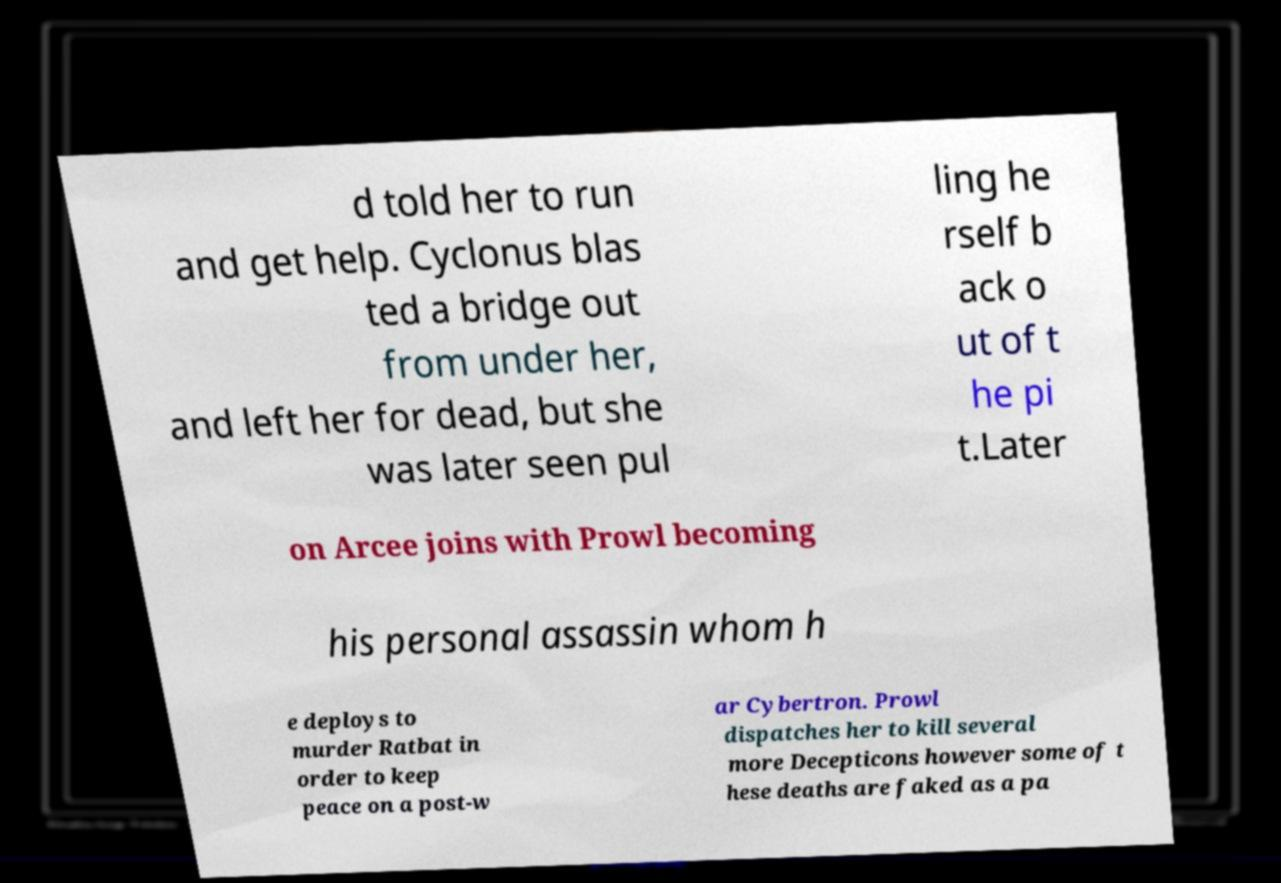Can you read and provide the text displayed in the image?This photo seems to have some interesting text. Can you extract and type it out for me? d told her to run and get help. Cyclonus blas ted a bridge out from under her, and left her for dead, but she was later seen pul ling he rself b ack o ut of t he pi t.Later on Arcee joins with Prowl becoming his personal assassin whom h e deploys to murder Ratbat in order to keep peace on a post-w ar Cybertron. Prowl dispatches her to kill several more Decepticons however some of t hese deaths are faked as a pa 